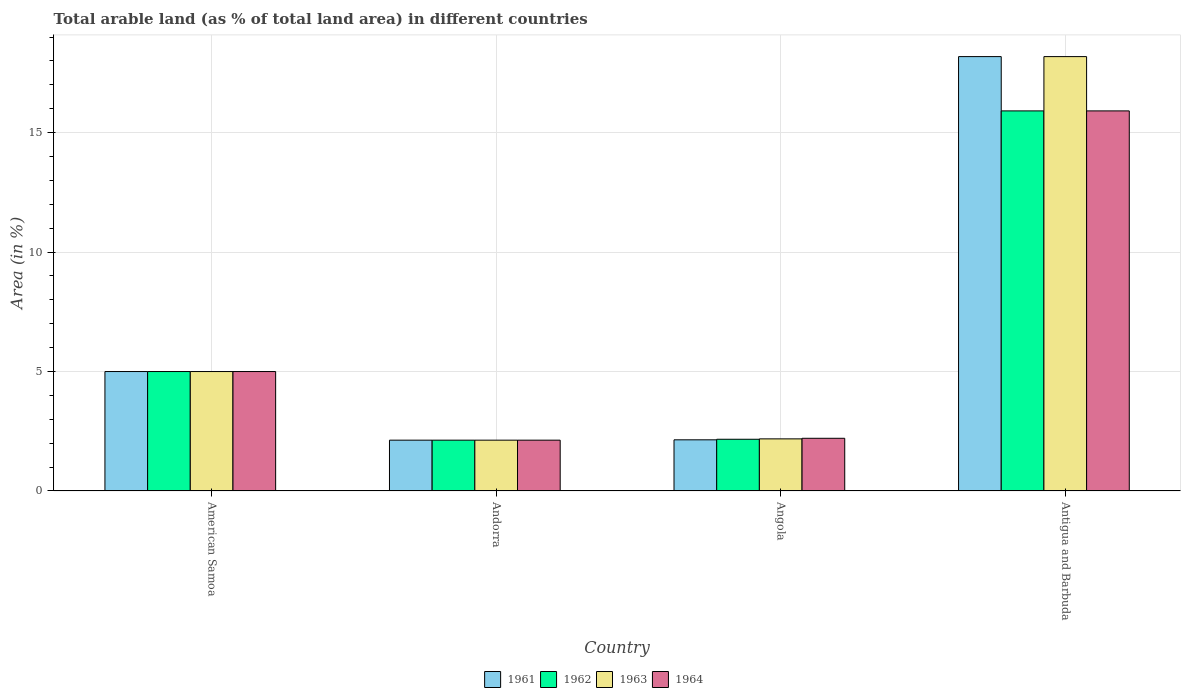How many groups of bars are there?
Your response must be concise. 4. How many bars are there on the 1st tick from the left?
Provide a short and direct response. 4. What is the label of the 2nd group of bars from the left?
Provide a short and direct response. Andorra. In how many cases, is the number of bars for a given country not equal to the number of legend labels?
Offer a very short reply. 0. What is the percentage of arable land in 1964 in Andorra?
Give a very brief answer. 2.13. Across all countries, what is the maximum percentage of arable land in 1961?
Provide a succinct answer. 18.18. Across all countries, what is the minimum percentage of arable land in 1961?
Give a very brief answer. 2.13. In which country was the percentage of arable land in 1961 maximum?
Make the answer very short. Antigua and Barbuda. In which country was the percentage of arable land in 1962 minimum?
Offer a very short reply. Andorra. What is the total percentage of arable land in 1961 in the graph?
Make the answer very short. 27.45. What is the difference between the percentage of arable land in 1964 in Andorra and that in Antigua and Barbuda?
Your answer should be very brief. -13.78. What is the difference between the percentage of arable land in 1962 in American Samoa and the percentage of arable land in 1961 in Andorra?
Make the answer very short. 2.87. What is the average percentage of arable land in 1964 per country?
Your answer should be compact. 6.31. What is the difference between the percentage of arable land of/in 1963 and percentage of arable land of/in 1961 in Angola?
Provide a succinct answer. 0.04. What is the ratio of the percentage of arable land in 1964 in American Samoa to that in Angola?
Make the answer very short. 2.27. Is the percentage of arable land in 1961 in Angola less than that in Antigua and Barbuda?
Your answer should be very brief. Yes. What is the difference between the highest and the second highest percentage of arable land in 1962?
Make the answer very short. -2.83. What is the difference between the highest and the lowest percentage of arable land in 1962?
Your response must be concise. 13.78. In how many countries, is the percentage of arable land in 1963 greater than the average percentage of arable land in 1963 taken over all countries?
Offer a very short reply. 1. What does the 4th bar from the right in Angola represents?
Your response must be concise. 1961. Is it the case that in every country, the sum of the percentage of arable land in 1963 and percentage of arable land in 1964 is greater than the percentage of arable land in 1961?
Offer a terse response. Yes. How many bars are there?
Keep it short and to the point. 16. How many countries are there in the graph?
Make the answer very short. 4. What is the difference between two consecutive major ticks on the Y-axis?
Provide a succinct answer. 5. Does the graph contain any zero values?
Your response must be concise. No. Does the graph contain grids?
Your response must be concise. Yes. How many legend labels are there?
Keep it short and to the point. 4. What is the title of the graph?
Ensure brevity in your answer.  Total arable land (as % of total land area) in different countries. Does "1999" appear as one of the legend labels in the graph?
Keep it short and to the point. No. What is the label or title of the X-axis?
Make the answer very short. Country. What is the label or title of the Y-axis?
Provide a succinct answer. Area (in %). What is the Area (in %) in 1961 in American Samoa?
Keep it short and to the point. 5. What is the Area (in %) of 1962 in American Samoa?
Make the answer very short. 5. What is the Area (in %) in 1963 in American Samoa?
Provide a succinct answer. 5. What is the Area (in %) of 1961 in Andorra?
Your answer should be very brief. 2.13. What is the Area (in %) in 1962 in Andorra?
Give a very brief answer. 2.13. What is the Area (in %) of 1963 in Andorra?
Your answer should be compact. 2.13. What is the Area (in %) of 1964 in Andorra?
Give a very brief answer. 2.13. What is the Area (in %) in 1961 in Angola?
Offer a very short reply. 2.14. What is the Area (in %) of 1962 in Angola?
Offer a terse response. 2.17. What is the Area (in %) in 1963 in Angola?
Your answer should be compact. 2.18. What is the Area (in %) of 1964 in Angola?
Provide a short and direct response. 2.21. What is the Area (in %) in 1961 in Antigua and Barbuda?
Offer a terse response. 18.18. What is the Area (in %) in 1962 in Antigua and Barbuda?
Your answer should be very brief. 15.91. What is the Area (in %) of 1963 in Antigua and Barbuda?
Make the answer very short. 18.18. What is the Area (in %) of 1964 in Antigua and Barbuda?
Provide a short and direct response. 15.91. Across all countries, what is the maximum Area (in %) in 1961?
Keep it short and to the point. 18.18. Across all countries, what is the maximum Area (in %) of 1962?
Your response must be concise. 15.91. Across all countries, what is the maximum Area (in %) of 1963?
Ensure brevity in your answer.  18.18. Across all countries, what is the maximum Area (in %) of 1964?
Provide a succinct answer. 15.91. Across all countries, what is the minimum Area (in %) in 1961?
Make the answer very short. 2.13. Across all countries, what is the minimum Area (in %) of 1962?
Offer a very short reply. 2.13. Across all countries, what is the minimum Area (in %) of 1963?
Offer a very short reply. 2.13. Across all countries, what is the minimum Area (in %) of 1964?
Make the answer very short. 2.13. What is the total Area (in %) of 1961 in the graph?
Offer a terse response. 27.45. What is the total Area (in %) of 1962 in the graph?
Keep it short and to the point. 25.2. What is the total Area (in %) of 1963 in the graph?
Ensure brevity in your answer.  27.49. What is the total Area (in %) in 1964 in the graph?
Offer a terse response. 25.24. What is the difference between the Area (in %) in 1961 in American Samoa and that in Andorra?
Provide a short and direct response. 2.87. What is the difference between the Area (in %) of 1962 in American Samoa and that in Andorra?
Give a very brief answer. 2.87. What is the difference between the Area (in %) of 1963 in American Samoa and that in Andorra?
Provide a succinct answer. 2.87. What is the difference between the Area (in %) in 1964 in American Samoa and that in Andorra?
Your answer should be compact. 2.87. What is the difference between the Area (in %) in 1961 in American Samoa and that in Angola?
Provide a succinct answer. 2.86. What is the difference between the Area (in %) in 1962 in American Samoa and that in Angola?
Keep it short and to the point. 2.83. What is the difference between the Area (in %) in 1963 in American Samoa and that in Angola?
Provide a short and direct response. 2.82. What is the difference between the Area (in %) in 1964 in American Samoa and that in Angola?
Your answer should be very brief. 2.79. What is the difference between the Area (in %) of 1961 in American Samoa and that in Antigua and Barbuda?
Your answer should be compact. -13.18. What is the difference between the Area (in %) in 1962 in American Samoa and that in Antigua and Barbuda?
Your answer should be compact. -10.91. What is the difference between the Area (in %) in 1963 in American Samoa and that in Antigua and Barbuda?
Ensure brevity in your answer.  -13.18. What is the difference between the Area (in %) of 1964 in American Samoa and that in Antigua and Barbuda?
Offer a terse response. -10.91. What is the difference between the Area (in %) of 1961 in Andorra and that in Angola?
Offer a very short reply. -0.01. What is the difference between the Area (in %) of 1962 in Andorra and that in Angola?
Keep it short and to the point. -0.04. What is the difference between the Area (in %) of 1963 in Andorra and that in Angola?
Ensure brevity in your answer.  -0.05. What is the difference between the Area (in %) of 1964 in Andorra and that in Angola?
Ensure brevity in your answer.  -0.08. What is the difference between the Area (in %) in 1961 in Andorra and that in Antigua and Barbuda?
Your response must be concise. -16.05. What is the difference between the Area (in %) of 1962 in Andorra and that in Antigua and Barbuda?
Provide a succinct answer. -13.78. What is the difference between the Area (in %) of 1963 in Andorra and that in Antigua and Barbuda?
Offer a terse response. -16.05. What is the difference between the Area (in %) in 1964 in Andorra and that in Antigua and Barbuda?
Provide a succinct answer. -13.78. What is the difference between the Area (in %) of 1961 in Angola and that in Antigua and Barbuda?
Ensure brevity in your answer.  -16.04. What is the difference between the Area (in %) in 1962 in Angola and that in Antigua and Barbuda?
Keep it short and to the point. -13.74. What is the difference between the Area (in %) in 1963 in Angola and that in Antigua and Barbuda?
Offer a very short reply. -16. What is the difference between the Area (in %) in 1964 in Angola and that in Antigua and Barbuda?
Provide a short and direct response. -13.7. What is the difference between the Area (in %) of 1961 in American Samoa and the Area (in %) of 1962 in Andorra?
Make the answer very short. 2.87. What is the difference between the Area (in %) in 1961 in American Samoa and the Area (in %) in 1963 in Andorra?
Keep it short and to the point. 2.87. What is the difference between the Area (in %) of 1961 in American Samoa and the Area (in %) of 1964 in Andorra?
Offer a very short reply. 2.87. What is the difference between the Area (in %) in 1962 in American Samoa and the Area (in %) in 1963 in Andorra?
Keep it short and to the point. 2.87. What is the difference between the Area (in %) of 1962 in American Samoa and the Area (in %) of 1964 in Andorra?
Your answer should be compact. 2.87. What is the difference between the Area (in %) of 1963 in American Samoa and the Area (in %) of 1964 in Andorra?
Offer a very short reply. 2.87. What is the difference between the Area (in %) of 1961 in American Samoa and the Area (in %) of 1962 in Angola?
Make the answer very short. 2.83. What is the difference between the Area (in %) of 1961 in American Samoa and the Area (in %) of 1963 in Angola?
Provide a succinct answer. 2.82. What is the difference between the Area (in %) of 1961 in American Samoa and the Area (in %) of 1964 in Angola?
Your answer should be very brief. 2.79. What is the difference between the Area (in %) in 1962 in American Samoa and the Area (in %) in 1963 in Angola?
Your answer should be very brief. 2.82. What is the difference between the Area (in %) in 1962 in American Samoa and the Area (in %) in 1964 in Angola?
Provide a short and direct response. 2.79. What is the difference between the Area (in %) of 1963 in American Samoa and the Area (in %) of 1964 in Angola?
Give a very brief answer. 2.79. What is the difference between the Area (in %) in 1961 in American Samoa and the Area (in %) in 1962 in Antigua and Barbuda?
Ensure brevity in your answer.  -10.91. What is the difference between the Area (in %) in 1961 in American Samoa and the Area (in %) in 1963 in Antigua and Barbuda?
Offer a very short reply. -13.18. What is the difference between the Area (in %) in 1961 in American Samoa and the Area (in %) in 1964 in Antigua and Barbuda?
Your answer should be very brief. -10.91. What is the difference between the Area (in %) of 1962 in American Samoa and the Area (in %) of 1963 in Antigua and Barbuda?
Make the answer very short. -13.18. What is the difference between the Area (in %) of 1962 in American Samoa and the Area (in %) of 1964 in Antigua and Barbuda?
Ensure brevity in your answer.  -10.91. What is the difference between the Area (in %) of 1963 in American Samoa and the Area (in %) of 1964 in Antigua and Barbuda?
Make the answer very short. -10.91. What is the difference between the Area (in %) of 1961 in Andorra and the Area (in %) of 1962 in Angola?
Your response must be concise. -0.04. What is the difference between the Area (in %) of 1961 in Andorra and the Area (in %) of 1963 in Angola?
Your response must be concise. -0.05. What is the difference between the Area (in %) in 1961 in Andorra and the Area (in %) in 1964 in Angola?
Your answer should be very brief. -0.08. What is the difference between the Area (in %) in 1962 in Andorra and the Area (in %) in 1963 in Angola?
Keep it short and to the point. -0.05. What is the difference between the Area (in %) in 1962 in Andorra and the Area (in %) in 1964 in Angola?
Make the answer very short. -0.08. What is the difference between the Area (in %) in 1963 in Andorra and the Area (in %) in 1964 in Angola?
Ensure brevity in your answer.  -0.08. What is the difference between the Area (in %) in 1961 in Andorra and the Area (in %) in 1962 in Antigua and Barbuda?
Your answer should be very brief. -13.78. What is the difference between the Area (in %) in 1961 in Andorra and the Area (in %) in 1963 in Antigua and Barbuda?
Make the answer very short. -16.05. What is the difference between the Area (in %) in 1961 in Andorra and the Area (in %) in 1964 in Antigua and Barbuda?
Offer a terse response. -13.78. What is the difference between the Area (in %) in 1962 in Andorra and the Area (in %) in 1963 in Antigua and Barbuda?
Provide a short and direct response. -16.05. What is the difference between the Area (in %) of 1962 in Andorra and the Area (in %) of 1964 in Antigua and Barbuda?
Offer a terse response. -13.78. What is the difference between the Area (in %) of 1963 in Andorra and the Area (in %) of 1964 in Antigua and Barbuda?
Keep it short and to the point. -13.78. What is the difference between the Area (in %) in 1961 in Angola and the Area (in %) in 1962 in Antigua and Barbuda?
Ensure brevity in your answer.  -13.77. What is the difference between the Area (in %) of 1961 in Angola and the Area (in %) of 1963 in Antigua and Barbuda?
Give a very brief answer. -16.04. What is the difference between the Area (in %) in 1961 in Angola and the Area (in %) in 1964 in Antigua and Barbuda?
Your answer should be very brief. -13.77. What is the difference between the Area (in %) of 1962 in Angola and the Area (in %) of 1963 in Antigua and Barbuda?
Your answer should be compact. -16.02. What is the difference between the Area (in %) in 1962 in Angola and the Area (in %) in 1964 in Antigua and Barbuda?
Your response must be concise. -13.74. What is the difference between the Area (in %) in 1963 in Angola and the Area (in %) in 1964 in Antigua and Barbuda?
Make the answer very short. -13.73. What is the average Area (in %) in 1961 per country?
Offer a terse response. 6.86. What is the average Area (in %) in 1962 per country?
Your response must be concise. 6.3. What is the average Area (in %) of 1963 per country?
Keep it short and to the point. 6.87. What is the average Area (in %) in 1964 per country?
Ensure brevity in your answer.  6.31. What is the difference between the Area (in %) of 1961 and Area (in %) of 1962 in American Samoa?
Your answer should be very brief. 0. What is the difference between the Area (in %) in 1961 and Area (in %) in 1964 in American Samoa?
Make the answer very short. 0. What is the difference between the Area (in %) in 1962 and Area (in %) in 1963 in American Samoa?
Offer a very short reply. 0. What is the difference between the Area (in %) in 1962 and Area (in %) in 1964 in American Samoa?
Offer a very short reply. 0. What is the difference between the Area (in %) of 1961 and Area (in %) of 1963 in Andorra?
Provide a succinct answer. 0. What is the difference between the Area (in %) of 1961 and Area (in %) of 1964 in Andorra?
Give a very brief answer. 0. What is the difference between the Area (in %) of 1962 and Area (in %) of 1963 in Andorra?
Make the answer very short. 0. What is the difference between the Area (in %) of 1962 and Area (in %) of 1964 in Andorra?
Your response must be concise. 0. What is the difference between the Area (in %) in 1963 and Area (in %) in 1964 in Andorra?
Your response must be concise. 0. What is the difference between the Area (in %) in 1961 and Area (in %) in 1962 in Angola?
Provide a short and direct response. -0.02. What is the difference between the Area (in %) in 1961 and Area (in %) in 1963 in Angola?
Keep it short and to the point. -0.04. What is the difference between the Area (in %) of 1961 and Area (in %) of 1964 in Angola?
Keep it short and to the point. -0.06. What is the difference between the Area (in %) in 1962 and Area (in %) in 1963 in Angola?
Offer a very short reply. -0.02. What is the difference between the Area (in %) of 1962 and Area (in %) of 1964 in Angola?
Make the answer very short. -0.04. What is the difference between the Area (in %) of 1963 and Area (in %) of 1964 in Angola?
Your answer should be very brief. -0.02. What is the difference between the Area (in %) in 1961 and Area (in %) in 1962 in Antigua and Barbuda?
Make the answer very short. 2.27. What is the difference between the Area (in %) of 1961 and Area (in %) of 1963 in Antigua and Barbuda?
Offer a very short reply. 0. What is the difference between the Area (in %) in 1961 and Area (in %) in 1964 in Antigua and Barbuda?
Provide a short and direct response. 2.27. What is the difference between the Area (in %) of 1962 and Area (in %) of 1963 in Antigua and Barbuda?
Keep it short and to the point. -2.27. What is the difference between the Area (in %) of 1963 and Area (in %) of 1964 in Antigua and Barbuda?
Provide a short and direct response. 2.27. What is the ratio of the Area (in %) in 1961 in American Samoa to that in Andorra?
Offer a very short reply. 2.35. What is the ratio of the Area (in %) of 1962 in American Samoa to that in Andorra?
Make the answer very short. 2.35. What is the ratio of the Area (in %) in 1963 in American Samoa to that in Andorra?
Offer a terse response. 2.35. What is the ratio of the Area (in %) in 1964 in American Samoa to that in Andorra?
Your answer should be compact. 2.35. What is the ratio of the Area (in %) of 1961 in American Samoa to that in Angola?
Offer a terse response. 2.33. What is the ratio of the Area (in %) of 1962 in American Samoa to that in Angola?
Provide a succinct answer. 2.31. What is the ratio of the Area (in %) of 1963 in American Samoa to that in Angola?
Your response must be concise. 2.29. What is the ratio of the Area (in %) in 1964 in American Samoa to that in Angola?
Make the answer very short. 2.27. What is the ratio of the Area (in %) in 1961 in American Samoa to that in Antigua and Barbuda?
Your answer should be compact. 0.28. What is the ratio of the Area (in %) of 1962 in American Samoa to that in Antigua and Barbuda?
Ensure brevity in your answer.  0.31. What is the ratio of the Area (in %) of 1963 in American Samoa to that in Antigua and Barbuda?
Offer a very short reply. 0.28. What is the ratio of the Area (in %) in 1964 in American Samoa to that in Antigua and Barbuda?
Make the answer very short. 0.31. What is the ratio of the Area (in %) of 1962 in Andorra to that in Angola?
Make the answer very short. 0.98. What is the ratio of the Area (in %) of 1963 in Andorra to that in Angola?
Provide a succinct answer. 0.98. What is the ratio of the Area (in %) of 1964 in Andorra to that in Angola?
Offer a very short reply. 0.96. What is the ratio of the Area (in %) in 1961 in Andorra to that in Antigua and Barbuda?
Provide a short and direct response. 0.12. What is the ratio of the Area (in %) in 1962 in Andorra to that in Antigua and Barbuda?
Make the answer very short. 0.13. What is the ratio of the Area (in %) in 1963 in Andorra to that in Antigua and Barbuda?
Offer a terse response. 0.12. What is the ratio of the Area (in %) in 1964 in Andorra to that in Antigua and Barbuda?
Make the answer very short. 0.13. What is the ratio of the Area (in %) in 1961 in Angola to that in Antigua and Barbuda?
Make the answer very short. 0.12. What is the ratio of the Area (in %) in 1962 in Angola to that in Antigua and Barbuda?
Make the answer very short. 0.14. What is the ratio of the Area (in %) in 1963 in Angola to that in Antigua and Barbuda?
Provide a succinct answer. 0.12. What is the ratio of the Area (in %) of 1964 in Angola to that in Antigua and Barbuda?
Offer a terse response. 0.14. What is the difference between the highest and the second highest Area (in %) in 1961?
Keep it short and to the point. 13.18. What is the difference between the highest and the second highest Area (in %) of 1962?
Your answer should be compact. 10.91. What is the difference between the highest and the second highest Area (in %) in 1963?
Your answer should be very brief. 13.18. What is the difference between the highest and the second highest Area (in %) of 1964?
Your answer should be compact. 10.91. What is the difference between the highest and the lowest Area (in %) in 1961?
Make the answer very short. 16.05. What is the difference between the highest and the lowest Area (in %) of 1962?
Provide a short and direct response. 13.78. What is the difference between the highest and the lowest Area (in %) of 1963?
Ensure brevity in your answer.  16.05. What is the difference between the highest and the lowest Area (in %) in 1964?
Make the answer very short. 13.78. 